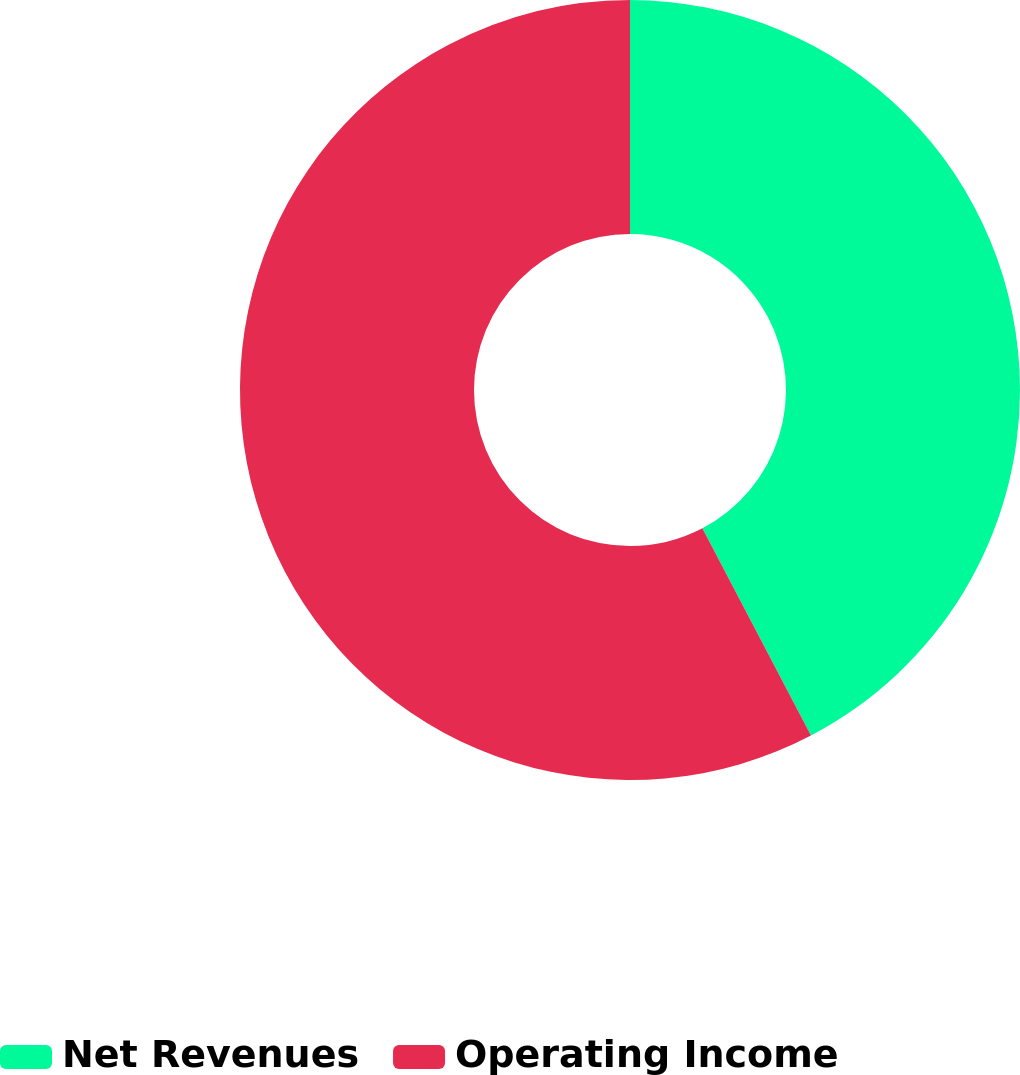Convert chart to OTSL. <chart><loc_0><loc_0><loc_500><loc_500><pie_chart><fcel>Net Revenues<fcel>Operating Income<nl><fcel>42.32%<fcel>57.68%<nl></chart> 